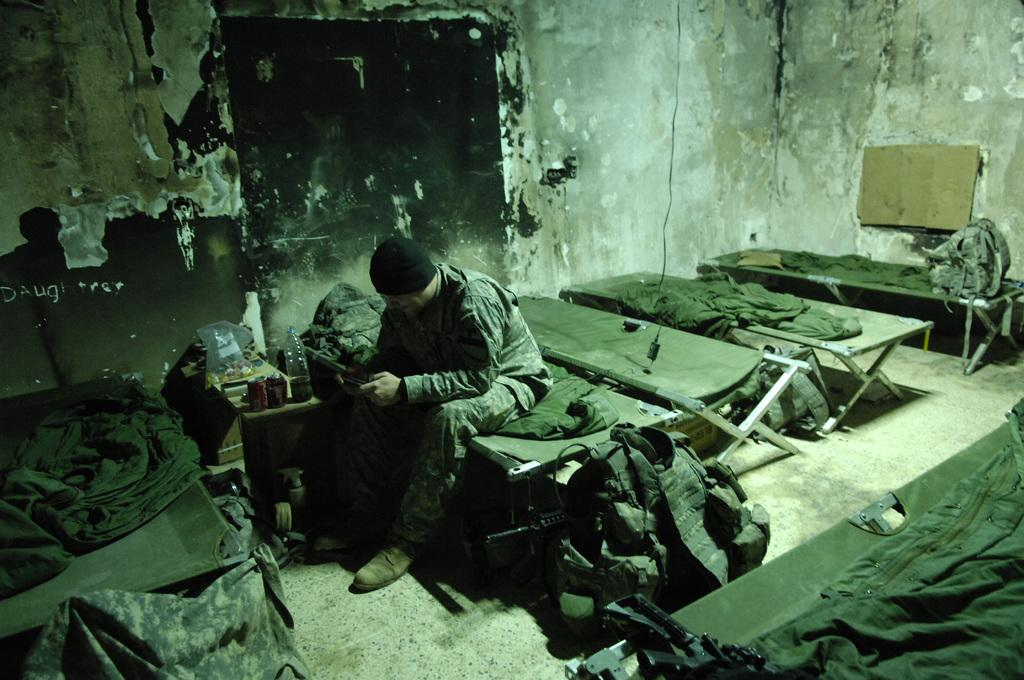What is the man in the image doing? The man is sitting on a cot in the image. What type of bedding is visible in the image? Bed sheets are present in the image. What items can be seen in the image that might be used for carrying or storing things? There are bags in the image. What type of container is visible in the image? There is a bottle in the image. What can be seen in the background of the image? There is a wall in the background of the image. What type of pies is the representative eating in the image? There is no representative or pies present in the image. What is the sack used for in the image? There is no sack present in the image. 